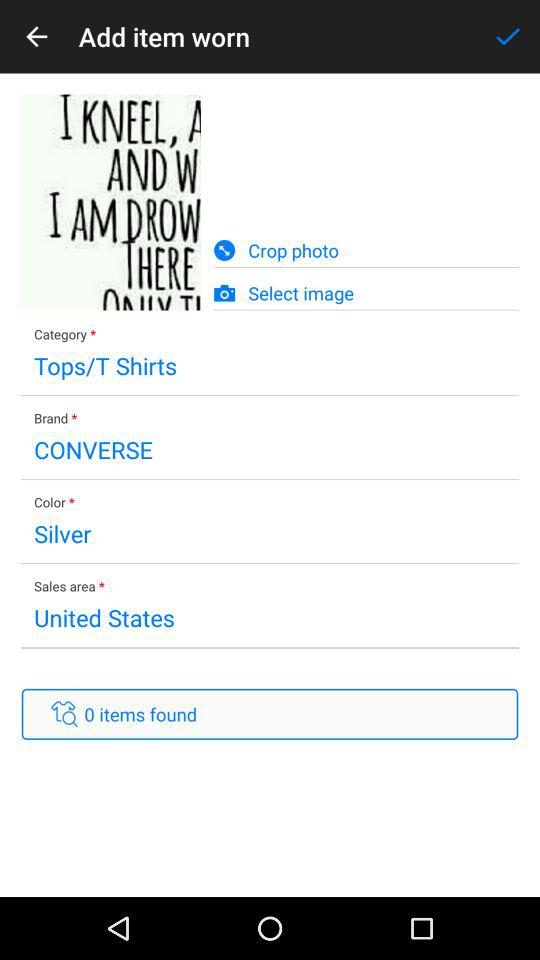What is the color of the cloth? The color of the cloth is silver. 